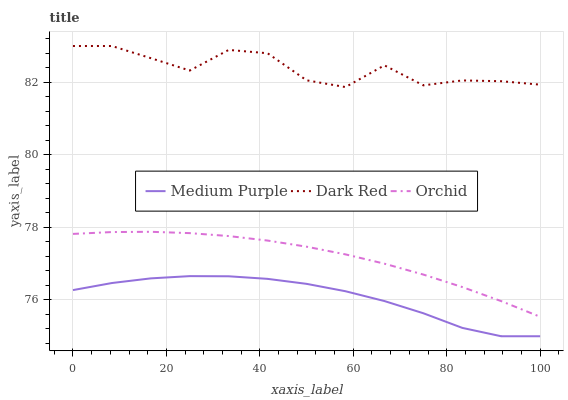Does Medium Purple have the minimum area under the curve?
Answer yes or no. Yes. Does Dark Red have the maximum area under the curve?
Answer yes or no. Yes. Does Orchid have the minimum area under the curve?
Answer yes or no. No. Does Orchid have the maximum area under the curve?
Answer yes or no. No. Is Orchid the smoothest?
Answer yes or no. Yes. Is Dark Red the roughest?
Answer yes or no. Yes. Is Dark Red the smoothest?
Answer yes or no. No. Is Orchid the roughest?
Answer yes or no. No. Does Medium Purple have the lowest value?
Answer yes or no. Yes. Does Orchid have the lowest value?
Answer yes or no. No. Does Dark Red have the highest value?
Answer yes or no. Yes. Does Orchid have the highest value?
Answer yes or no. No. Is Medium Purple less than Dark Red?
Answer yes or no. Yes. Is Orchid greater than Medium Purple?
Answer yes or no. Yes. Does Medium Purple intersect Dark Red?
Answer yes or no. No. 